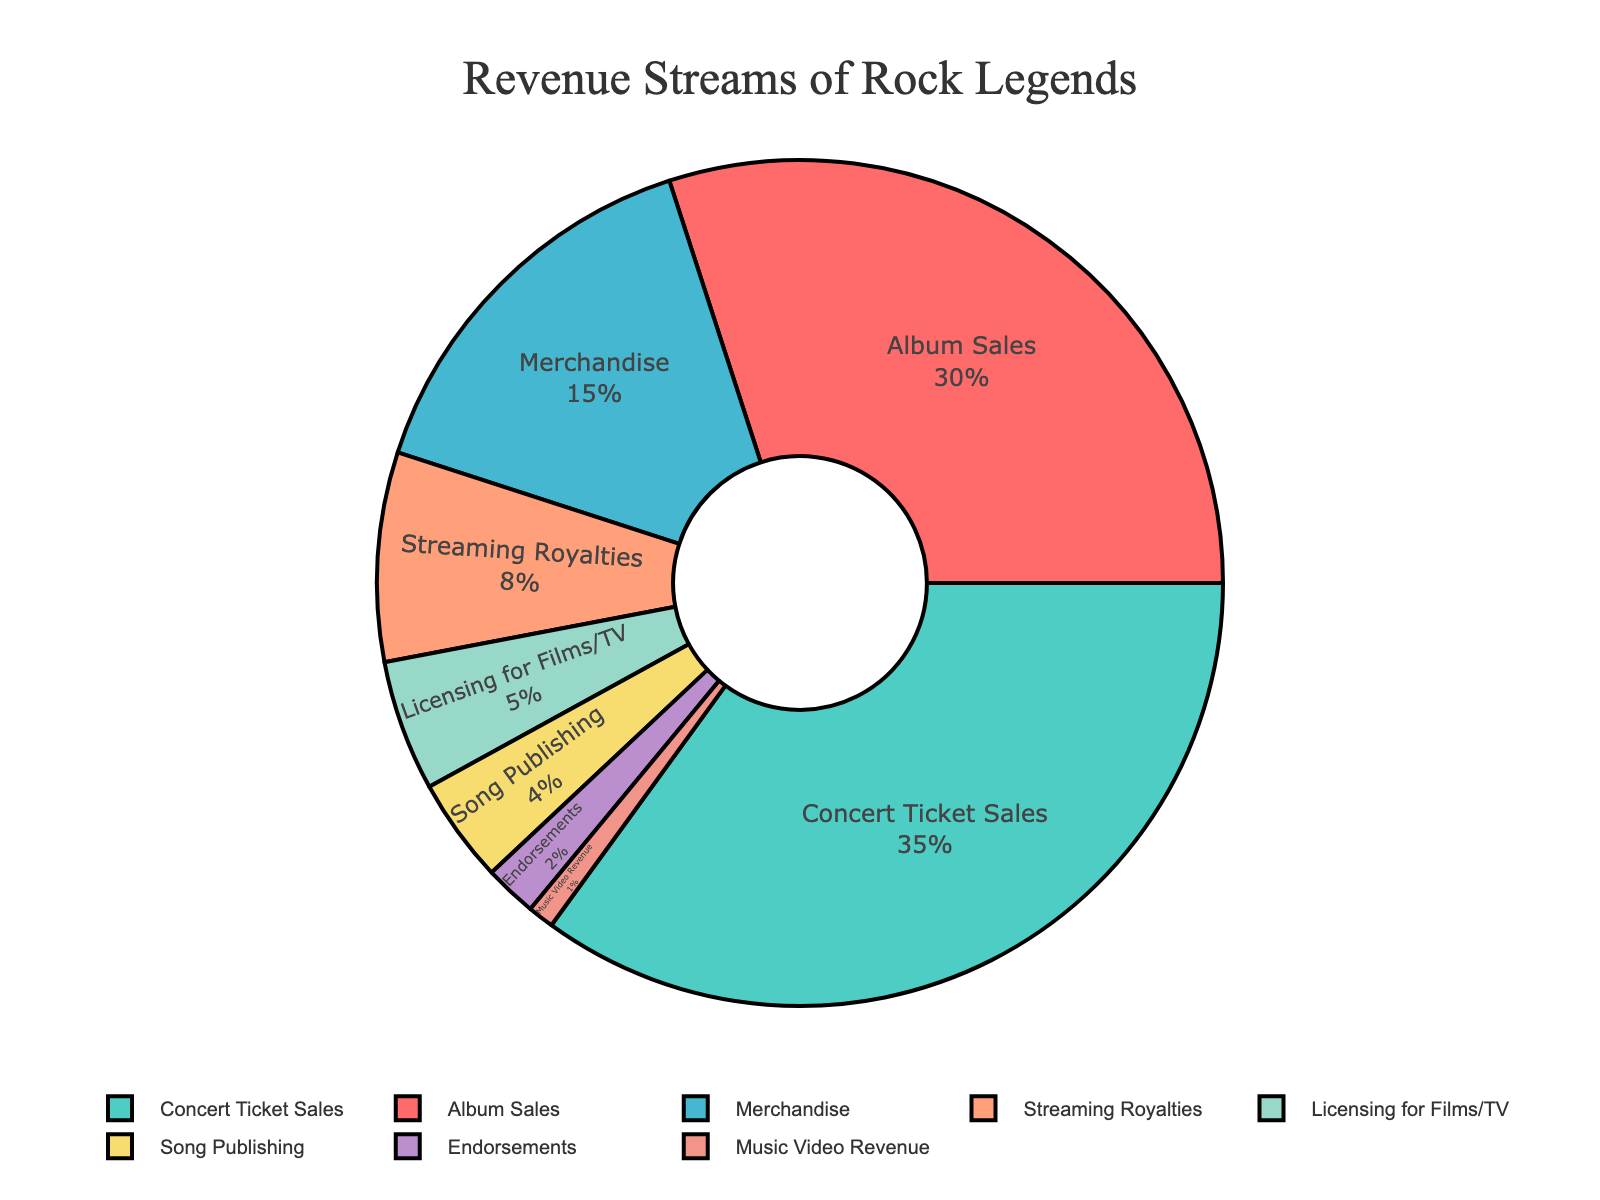What percentage of revenue comes from album sales and concert ticket sales combined? The pie chart shows that album sales account for 30% and concert ticket sales account for 35%. Combining these two percentages: 30% + 35% = 65%.
Answer: 65% Which revenue stream generates the most income? By looking at the pie chart, we can see that the largest segment is concert ticket sales, which is 35%.
Answer: Concert Ticket Sales How much more revenue does merchandise generate compared to streaming royalties? Merchandise generates 15%, while streaming royalties generate 8%. The difference between these two values is 15% - 8% = 7%.
Answer: 7% Are there any revenue streams that contribute the same percentage to the total revenue? By examining the pie chart, we can see that no two slices are identical in percentage. Thus, no revenue streams contribute the same percentage.
Answer: No What percentage of revenue comes from the smallest revenue stream? The smallest segment in the pie chart represents music video revenue, which accounts for 1% of the total revenue.
Answer: 1% Which two revenue streams together contribute the same percentage as album sales? Album sales contribute 30%. The two revenue streams that can be combined to equal this are streaming royalties (8%) and merchandise (15%), plus song publishing (4%) and music video revenue (1%). Adding these: 8% + 15% + 4% + 1% = 30%.
Answer: Streaming Royalties, Merchandise How does the revenue generated by licensing for films/TV compare to endorsements? Licensing for Films/TV accounts for 5% and endorsements account for 2%. Licensing for Films/TV generates more revenue than endorsements.
Answer: Licensing for Films/TV What is the total revenue percentage from non-music-related streams? (consider Endorsements and Licensing for Films/TV) Endorsements account for 2% and licensing for films/TV accounts for 5%. Adding these: 2% + 5% = 7%.
Answer: 7% What color represents the revenue stream for concert ticket sales? Inspecting the pie chart, we can see that the segment for concert ticket sales is shown in green.
Answer: Green If revenue from streaming royalties doubled, what would its new percentage be, and would it surpass the percentage from merchandise? Streaming royalties currently account for 8%. If it doubled, it would be 8% * 2 = 16%. Compared to merchandise (which is 15%), 16% is larger.
Answer: 16%, Yes 